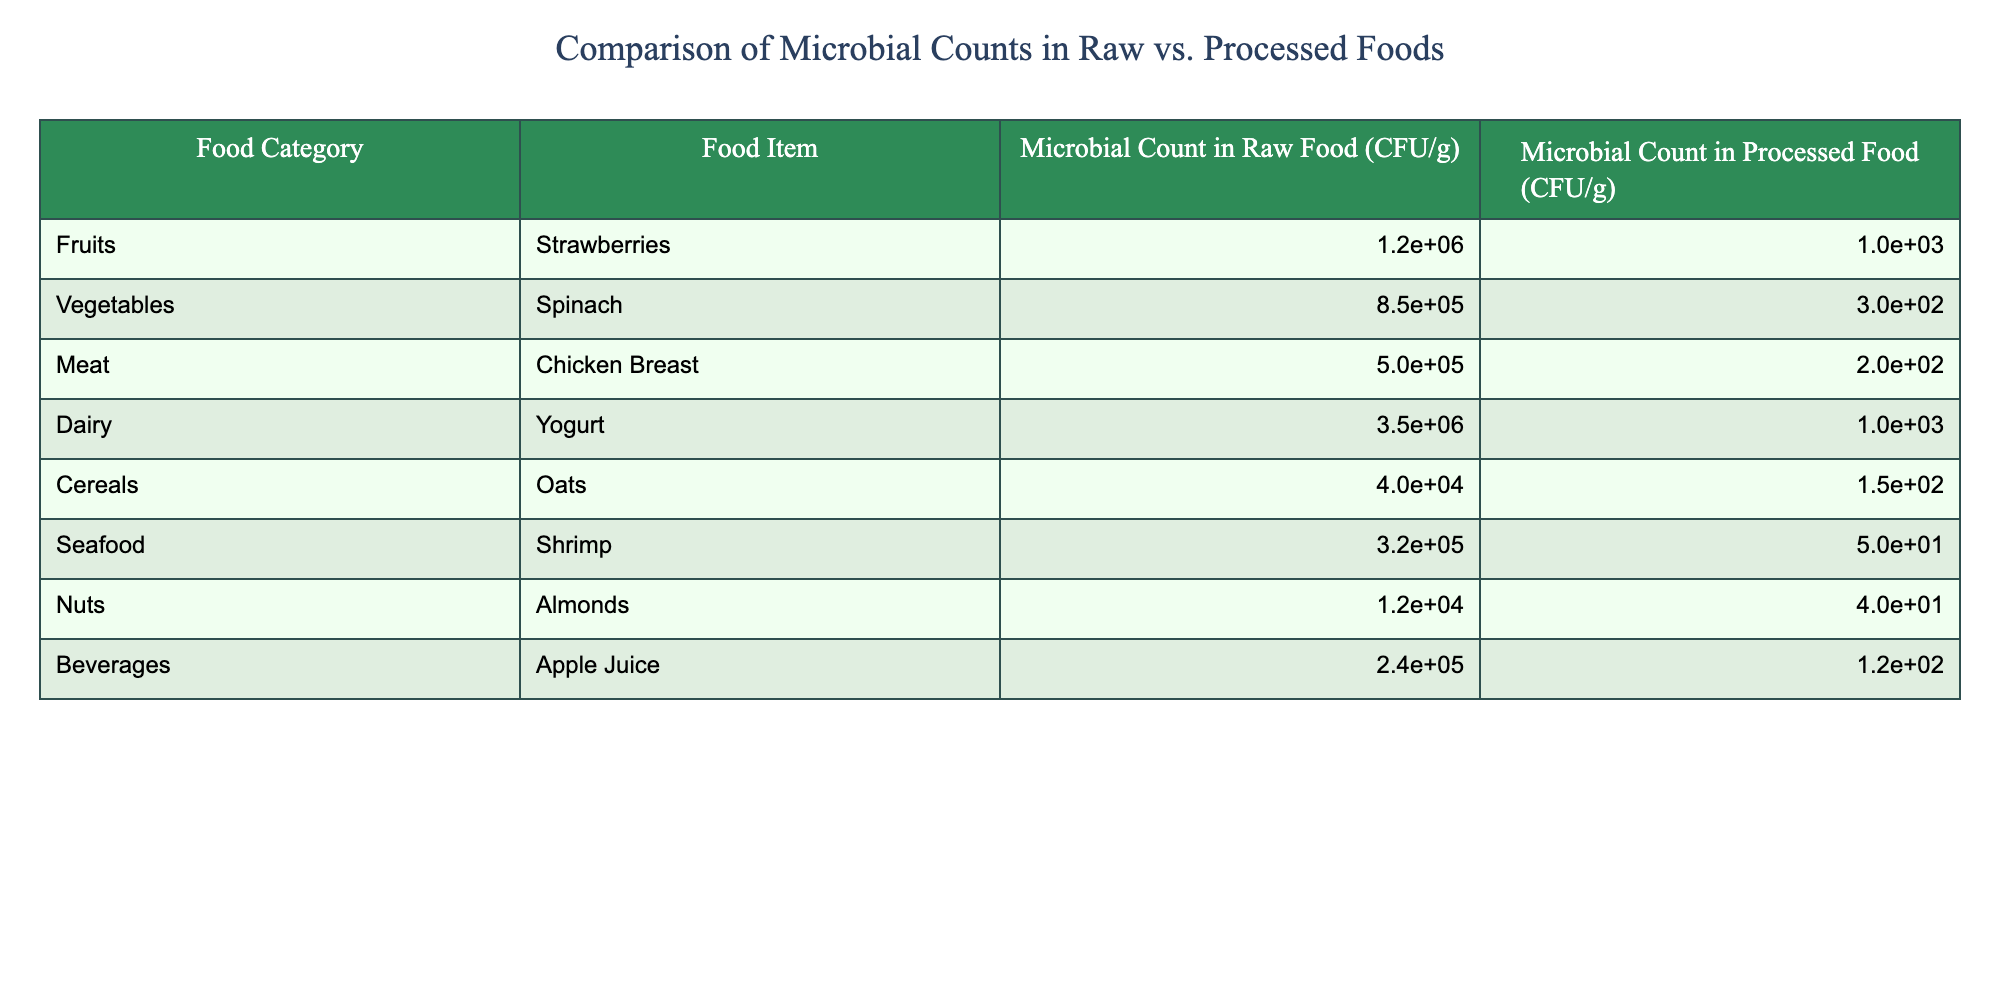What is the microbial count in raw strawberries? The table lists the microbial count in raw strawberries as 1.2e6 CFU/g.
Answer: 1.2e6 CFU/g Which food item has the highest microbial count in processed food? The values in the processed food column are compared, and yogurt has the highest count at 1.0e3 CFU/g.
Answer: Yogurt Is the microbial count in processed chicken breast lower than in processed spinach? The processed counts are 2.0e2 CFU/g for chicken breast and 3.0e2 CFU/g for spinach. Since 2.0e2 is lower than 3.0e2, the statement is true.
Answer: Yes What is the difference in microbial counts between raw and processed oats? The raw count of oats is 4.0e4 CFU/g and the processed count is 1.5e2 CFU/g. The difference is calculated as (4.0e4 - 1.5e2) = 3.985e4 CFU/g.
Answer: 3.985e4 CFU/g Which food category shows the largest reduction in microbial counts from raw to processed foods? The highest raw count is in dairy (3.5e6 CFU/g) and its processed count is 1.0e3 CFU/g. The reduction is (3.5e6 - 1.0e3) = 3.499e6 CFU/g, which is larger than any other category's reduction.
Answer: Dairy What is the average microbial count in raw food across all categories? To find the average, sum all raw counts: (1.2e6 + 8.5e5 + 5.0e5 + 3.5e6 + 4.0e4 + 3.2e5 + 1.2e4 + 2.4e5) = 5.623e6, and divide by 8 (number of food items) gives an average of 7.029e5 CFU/g.
Answer: 7.029e5 CFU/g Are the microbial counts in processed seafood higher than in nuts? The processed seafood count is 5.0e1 CFU/g while the processed nuts count is 4.0e1 CFU/g. Since 5.0e1 is greater than 4.0e1, the answer is true.
Answer: Yes What is the ratio of microbial counts between raw and processed yogurt? The raw yogurt count is 3.5e6 CFU/g and the processed yogurt count is 1.0e3 CFU/g. The ratio is (3.5e6 / 1.0e3) = 3500.
Answer: 3500 